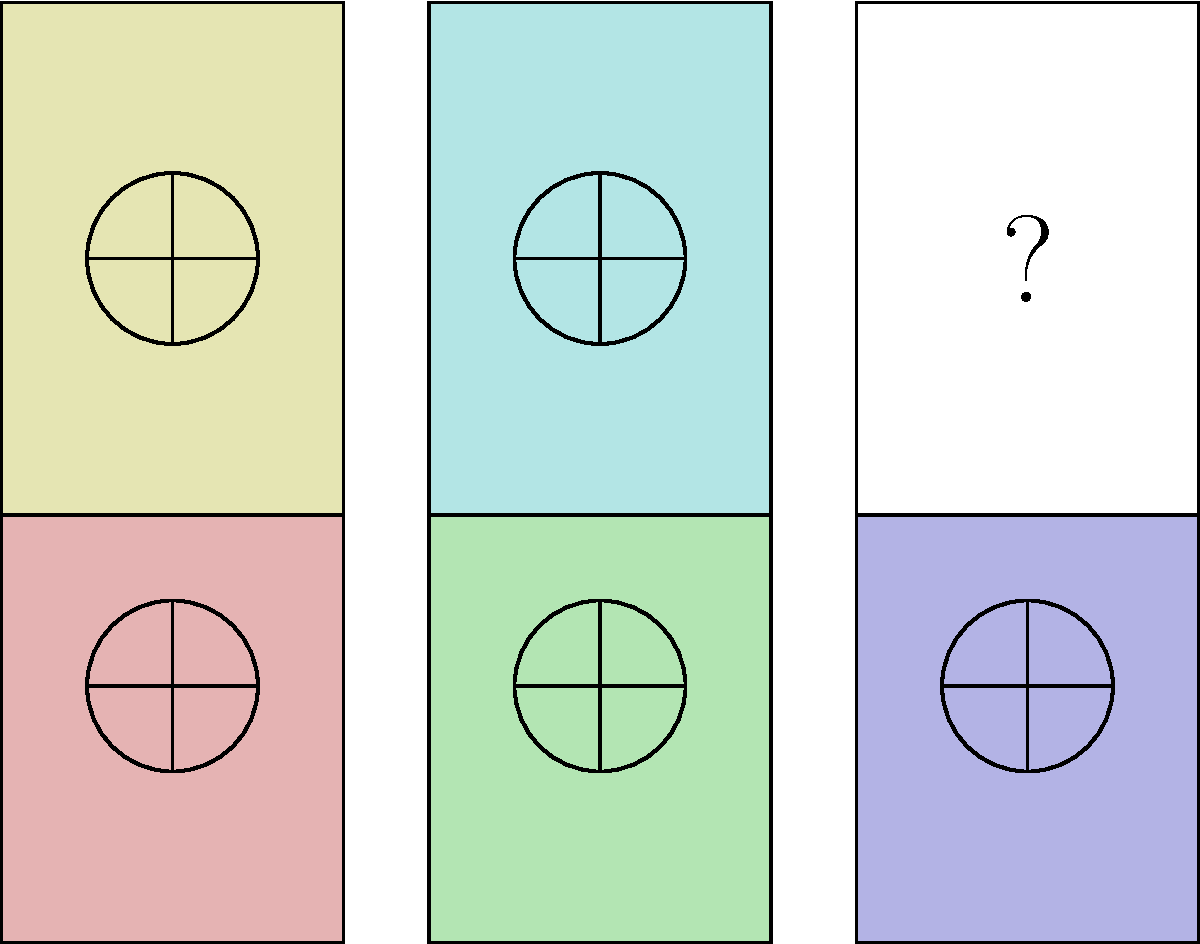Which pattern should replace the question mark in the sequence of spoken word poetry book designs? To determine the correct pattern for the last book, we need to analyze the existing patterns and their relationship to the book colors:

1. Observe that each book has a unique color, except for the last one which is white.
2. The pattern on each colored book consists of a circle with intersecting vertical and horizontal lines.
3. The pattern remains constant across all colored books, regardless of the book's color.
4. The white book (last in the sequence) is the only one without a pattern, indicated by the question mark.
5. Given that all other books follow the same pattern regardless of color, we can infer that the white book should also have this pattern to maintain consistency.
6. The consistency in pattern across different colors suggests that the content (spoken word poetry) is unified in its impact and presentation, despite variations in themes (represented by colors).

Therefore, the logical conclusion is that the white book should feature the same circle-and-intersecting-lines pattern as the other books, maintaining the visual consistency of the spoken word poetry collection.
Answer: Circle with intersecting vertical and horizontal lines 